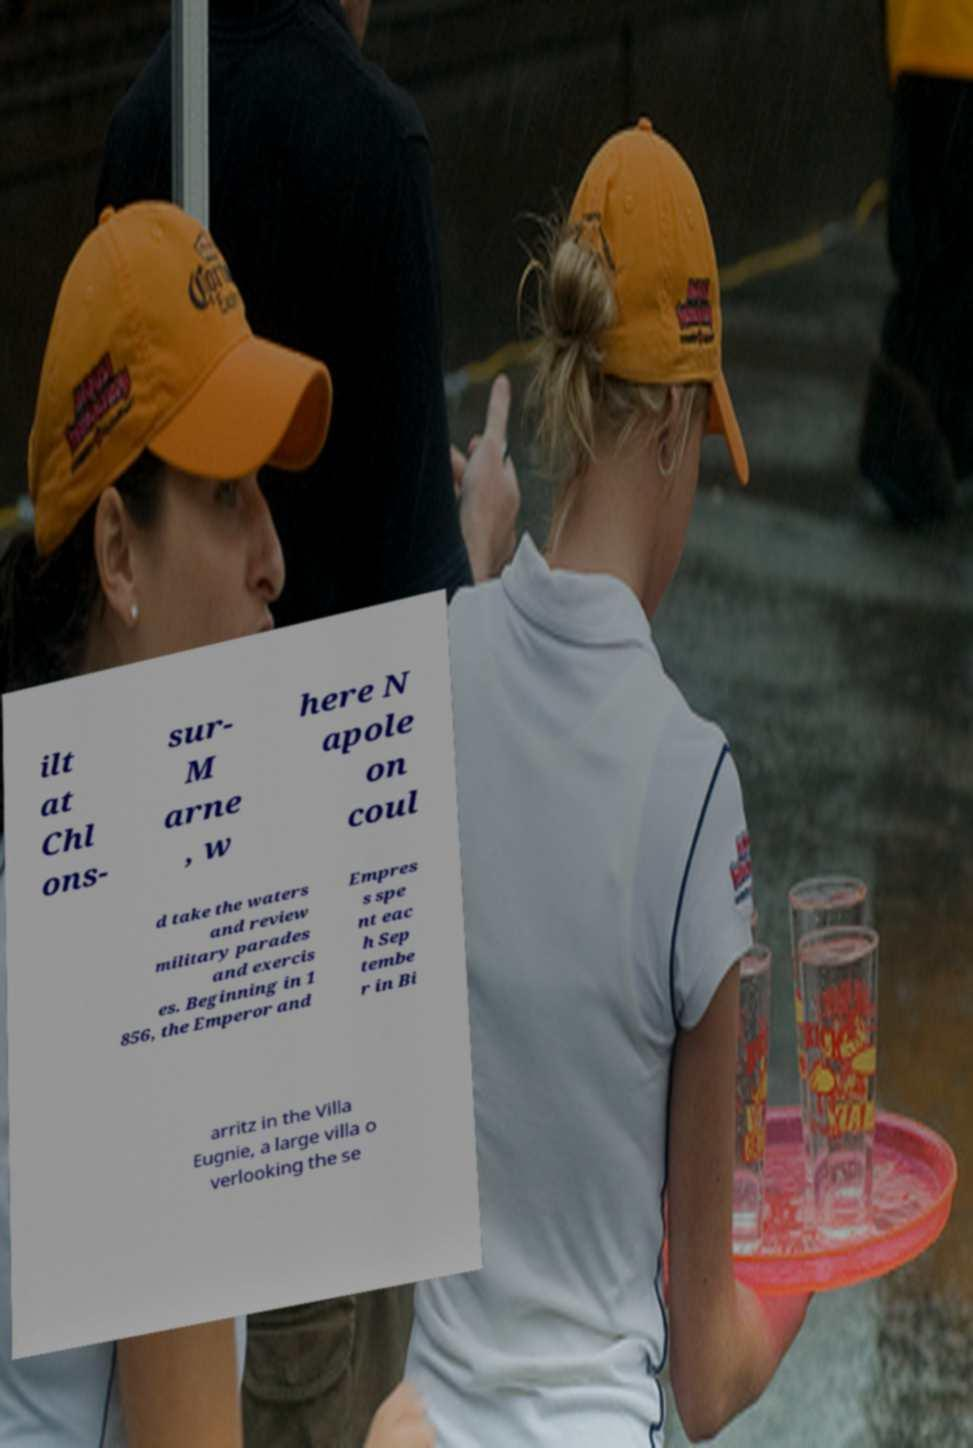Please read and relay the text visible in this image. What does it say? ilt at Chl ons- sur- M arne , w here N apole on coul d take the waters and review military parades and exercis es. Beginning in 1 856, the Emperor and Empres s spe nt eac h Sep tembe r in Bi arritz in the Villa Eugnie, a large villa o verlooking the se 